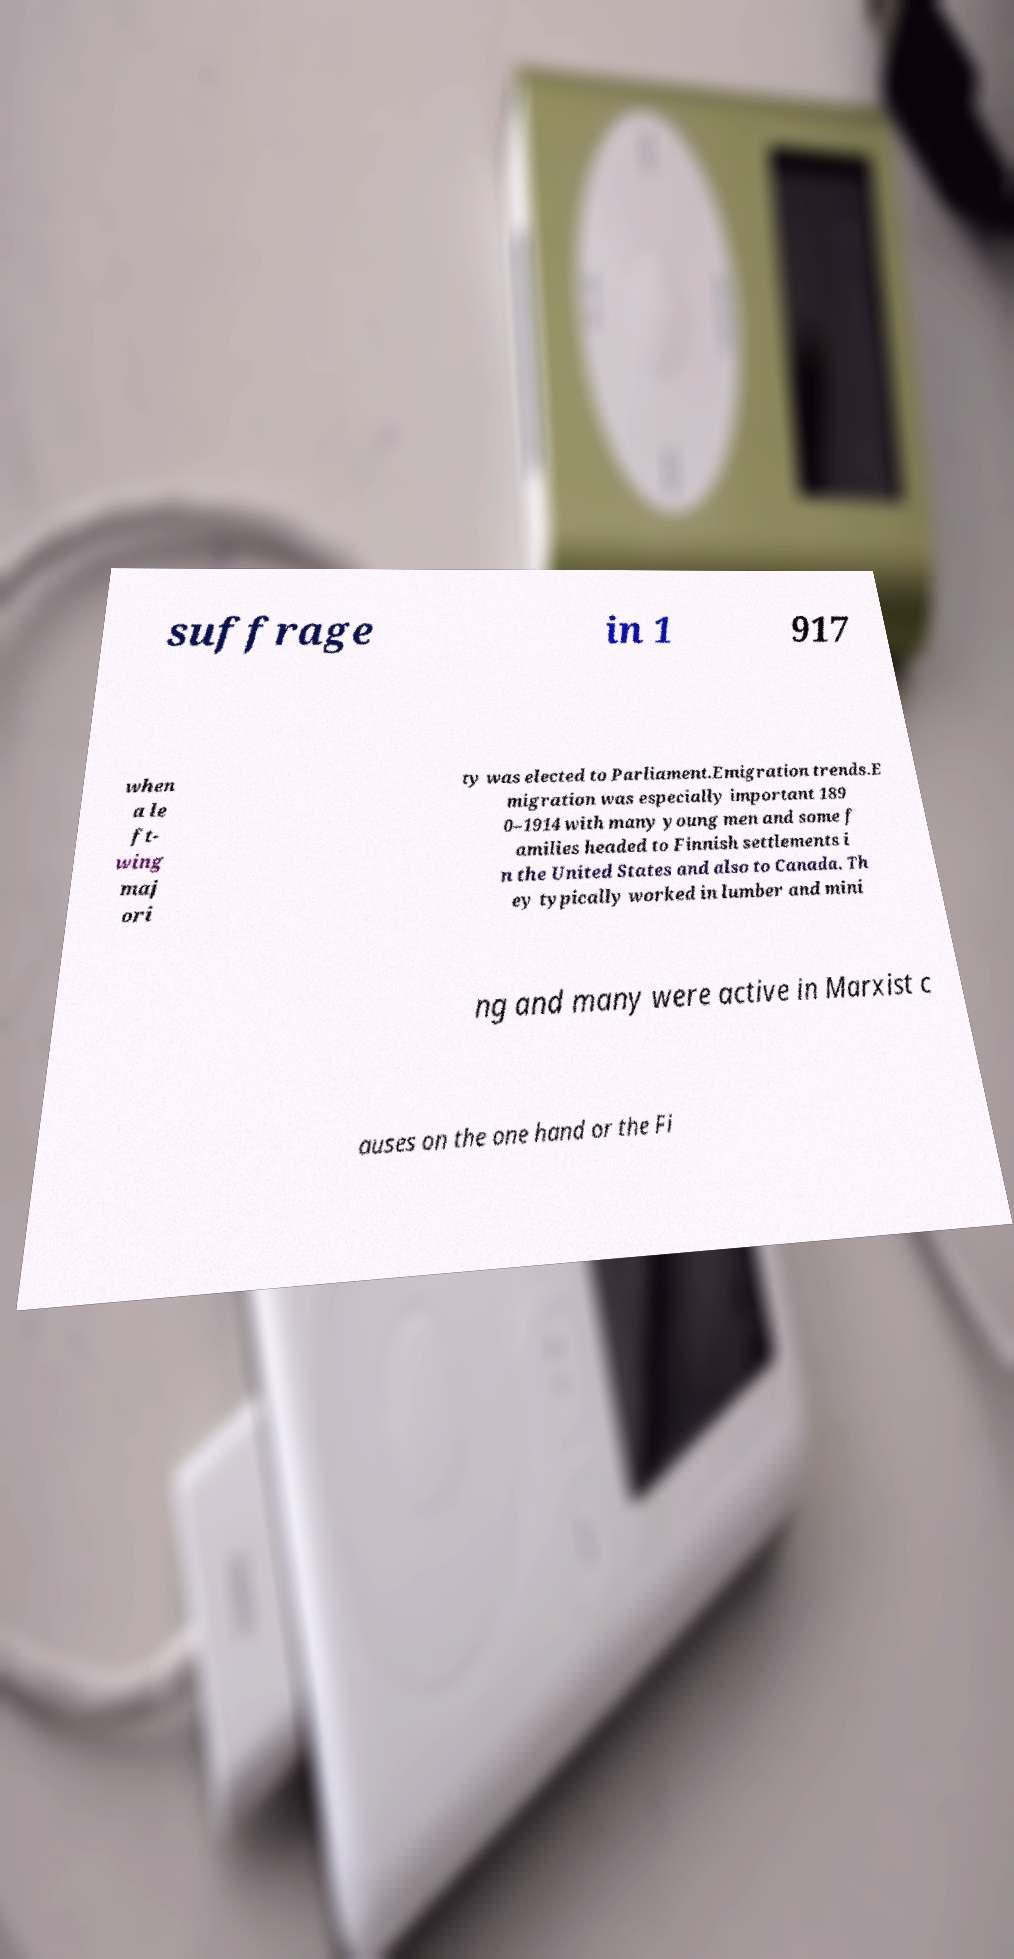I need the written content from this picture converted into text. Can you do that? suffrage in 1 917 when a le ft- wing maj ori ty was elected to Parliament.Emigration trends.E migration was especially important 189 0–1914 with many young men and some f amilies headed to Finnish settlements i n the United States and also to Canada. Th ey typically worked in lumber and mini ng and many were active in Marxist c auses on the one hand or the Fi 